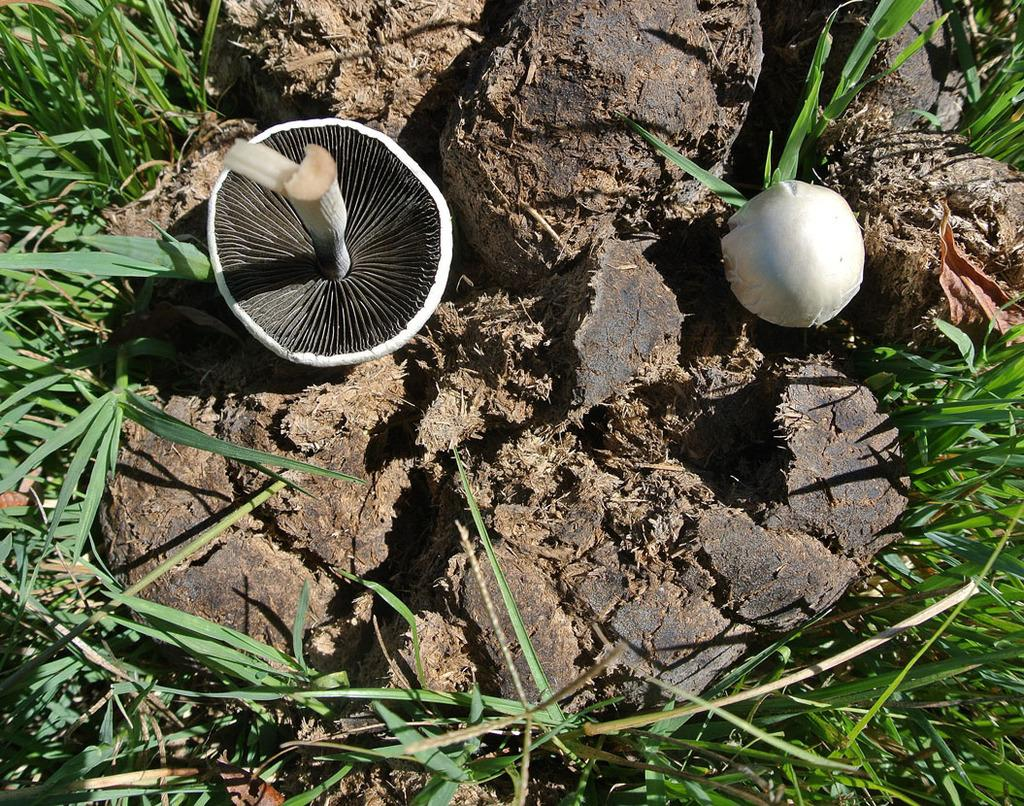What type of fungi can be seen in the image? There are mushrooms in the image. What is the texture of the substance next to the mushrooms? There is dung in the image. What type of vegetation is present in the image? There is green grass in the image. What type of toys can be seen in the image? There are no toys present in the image; it features mushrooms, dung, and green grass. How many pies are visible in the image? There are no pies present in the image. 